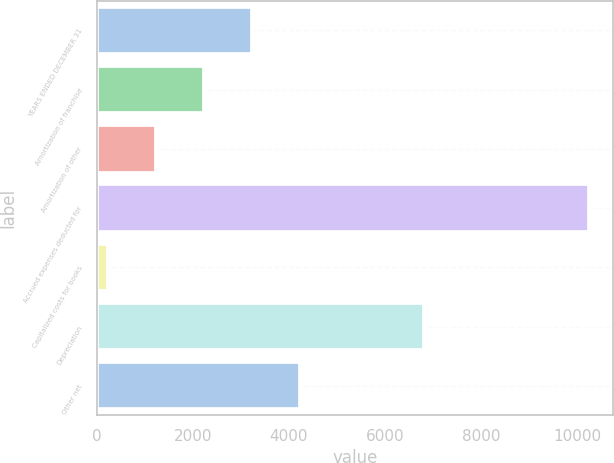Convert chart. <chart><loc_0><loc_0><loc_500><loc_500><bar_chart><fcel>YEARS ENDED DECEMBER 31<fcel>Amortization of franchise<fcel>Amortization of other<fcel>Accrued expenses deducted for<fcel>Capitalized costs for books<fcel>Depreciation<fcel>Other net<nl><fcel>3229.9<fcel>2228.6<fcel>1227.3<fcel>10239<fcel>226<fcel>6815<fcel>4231.2<nl></chart> 